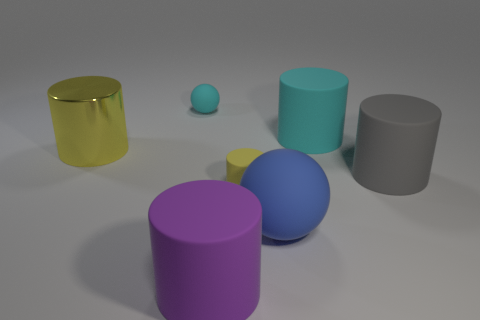Subtract all small yellow cylinders. How many cylinders are left? 4 Subtract all gray cylinders. How many cylinders are left? 4 Subtract all blue cylinders. Subtract all purple balls. How many cylinders are left? 5 Add 3 large red metallic objects. How many objects exist? 10 Subtract all cylinders. How many objects are left? 2 Add 2 big cylinders. How many big cylinders exist? 6 Subtract 0 gray blocks. How many objects are left? 7 Subtract all cyan things. Subtract all yellow matte things. How many objects are left? 4 Add 6 gray rubber cylinders. How many gray rubber cylinders are left? 7 